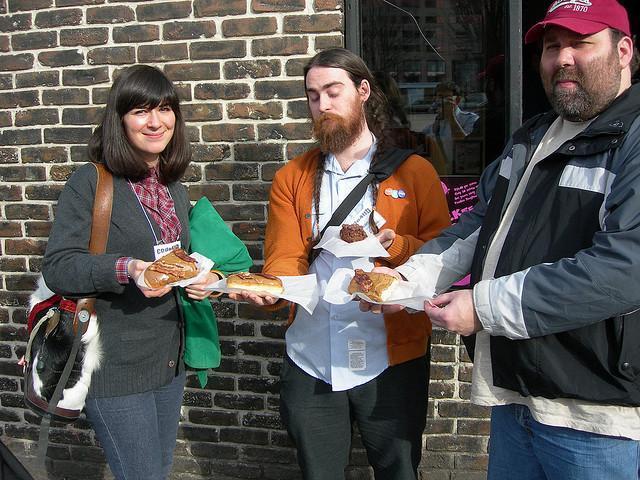How many people have beards?
Give a very brief answer. 2. How many people are there?
Give a very brief answer. 4. 